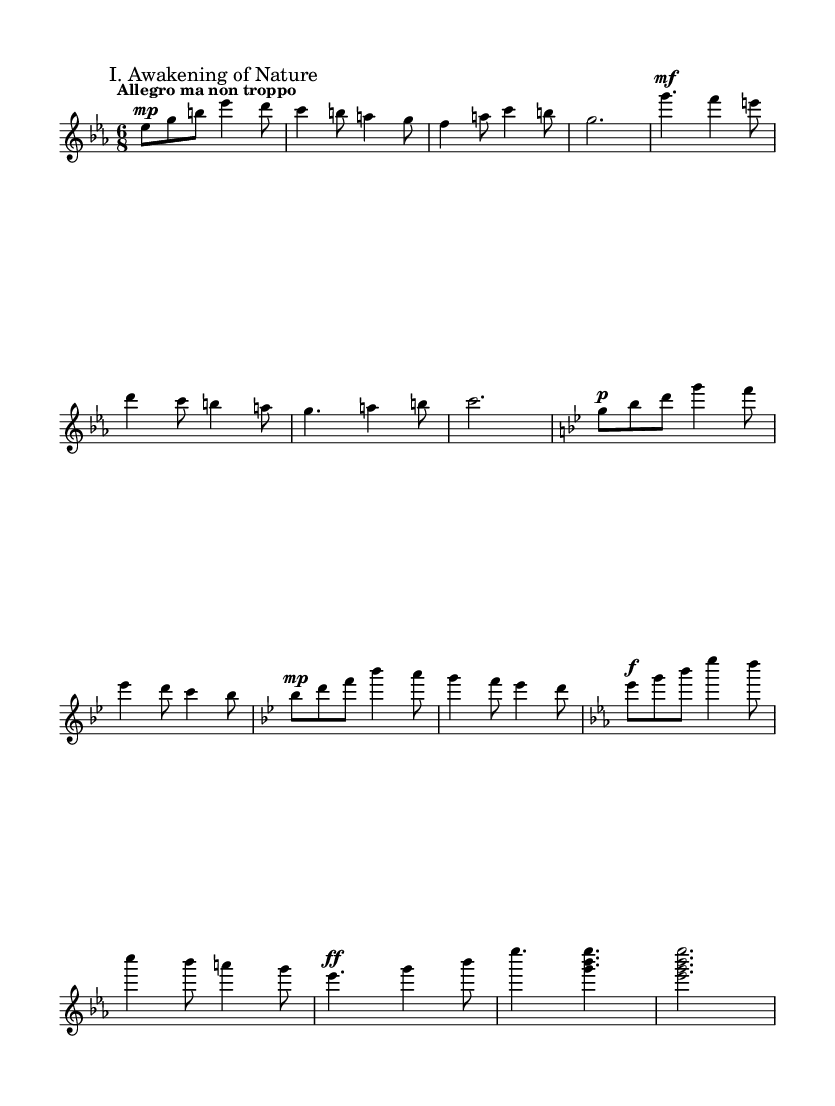What is the key signature of this music? The key signature at the beginning of the score indicates an Es major, which has three flats: B-flat, E-flat, and A-flat.
Answer: Es major What is the time signature of this piece? The time signature appears at the beginning, showing the piece is written in 6/8, which means there are six eighth notes per measure.
Answer: 6/8 What is the tempo marking of this score? The tempo marking "Allegro ma non troppo" is indicated above the staff at the start, guiding the performer to play lively but not too fast.
Answer: Allegro ma non troppo How many main themes are presented in this section? The score presents a main theme followed by a secondary theme; thus, there are two distinct themes.
Answer: Two What is the dynamic marking for the main theme? The main theme begins with a "mp" marking (mezzo-piano), indicating a moderately soft dynamic.
Answer: mp Which section presents a change in key signature? The section labeled "Development" involves a change in key signature, moving from Es major to G minor and then to B-flat major before returning to Es major.
Answer: Development What is the final dynamic marking in the coda? The final dynamic marking is "ff," which indicates a very loud dynamic at the end of the coda section.
Answer: ff 